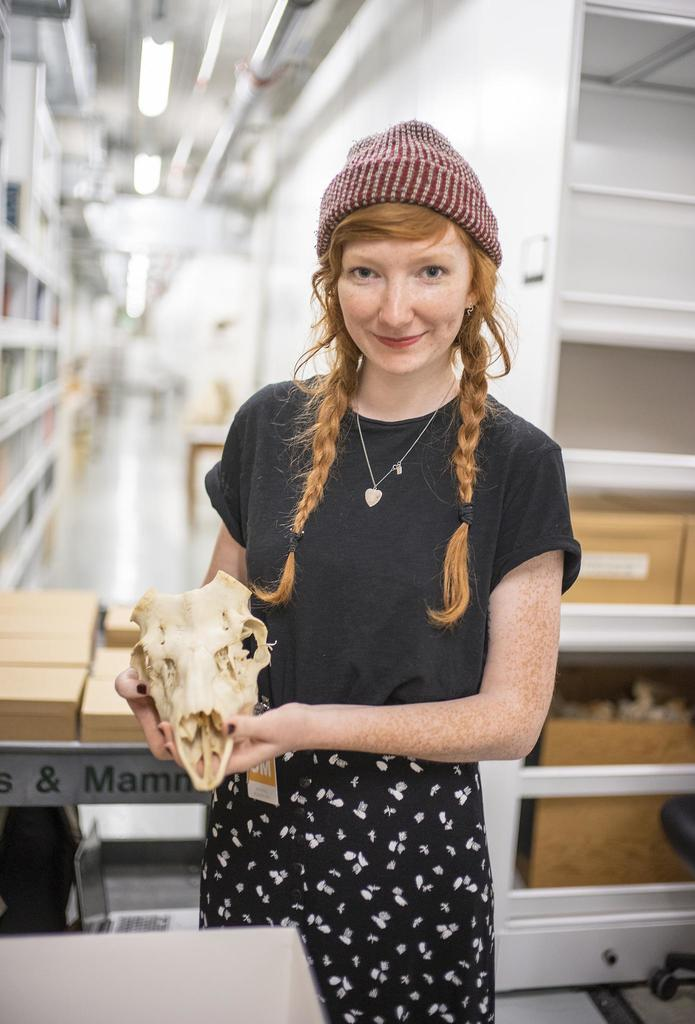What is the main subject of the image? The main subject of the image is a girl standing. What is the girl holding in the image? The girl is holding a skull of an animal. What type of furniture is present in the image? There is a table in the image. What other objects can be seen in the image? There are racks in the image. What type of polish is the girl applying to the skull in the image? There is no indication in the image that the girl is applying any polish to the skull. How many tomatoes are on the table in the image? There is no mention of tomatoes in the image; the focus is on the girl holding a skull and the presence of a table and racks. 